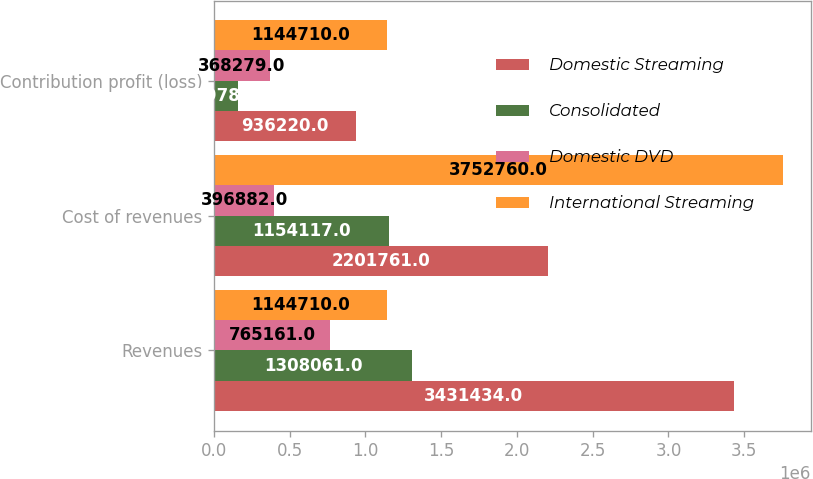<chart> <loc_0><loc_0><loc_500><loc_500><stacked_bar_chart><ecel><fcel>Revenues<fcel>Cost of revenues<fcel>Contribution profit (loss)<nl><fcel>Domestic Streaming<fcel>3.43143e+06<fcel>2.20176e+06<fcel>936220<nl><fcel>Consolidated<fcel>1.30806e+06<fcel>1.15412e+06<fcel>159789<nl><fcel>Domestic DVD<fcel>765161<fcel>396882<fcel>368279<nl><fcel>International Streaming<fcel>1.14471e+06<fcel>3.75276e+06<fcel>1.14471e+06<nl></chart> 